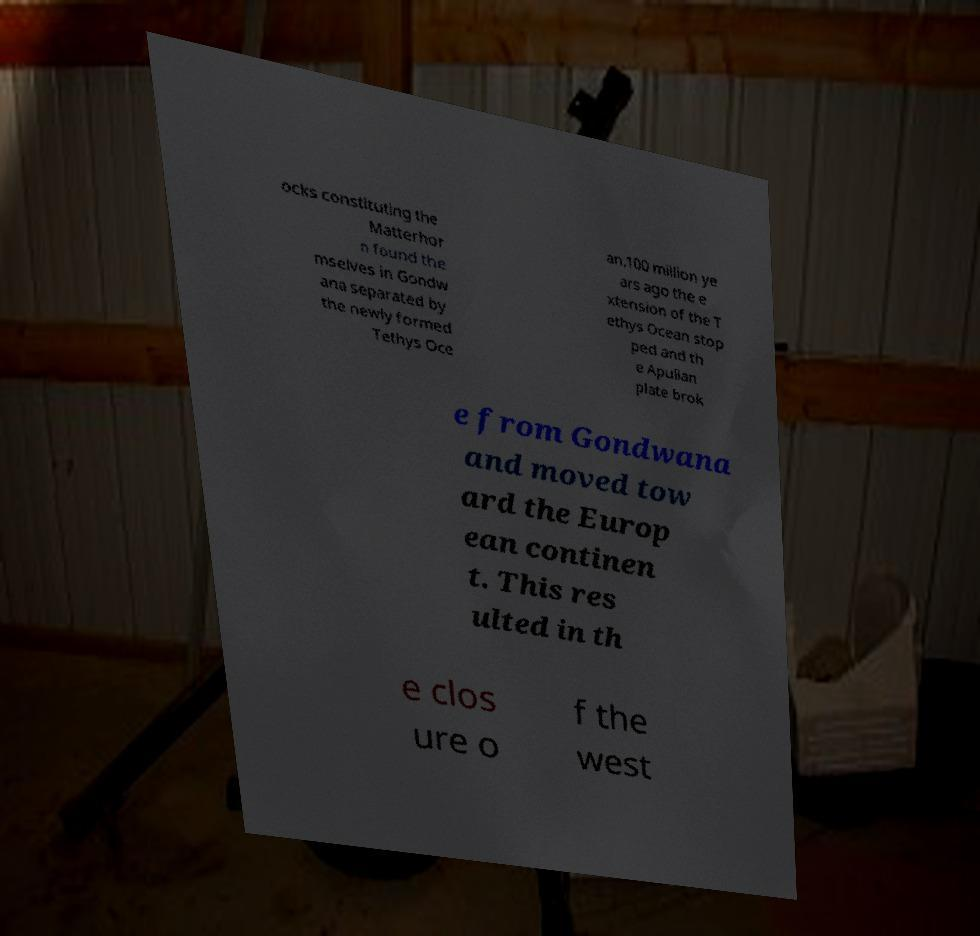Could you extract and type out the text from this image? ocks constituting the Matterhor n found the mselves in Gondw ana separated by the newly formed Tethys Oce an.100 million ye ars ago the e xtension of the T ethys Ocean stop ped and th e Apulian plate brok e from Gondwana and moved tow ard the Europ ean continen t. This res ulted in th e clos ure o f the west 